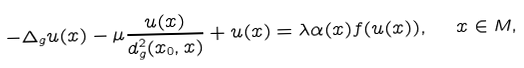Convert formula to latex. <formula><loc_0><loc_0><loc_500><loc_500>- \Delta _ { g } u ( x ) - \mu \frac { u ( x ) } { d ^ { 2 } _ { g } ( x _ { 0 } , x ) } + u ( x ) = \lambda \alpha ( x ) f ( u ( x ) ) , \ \ x \in M ,</formula> 